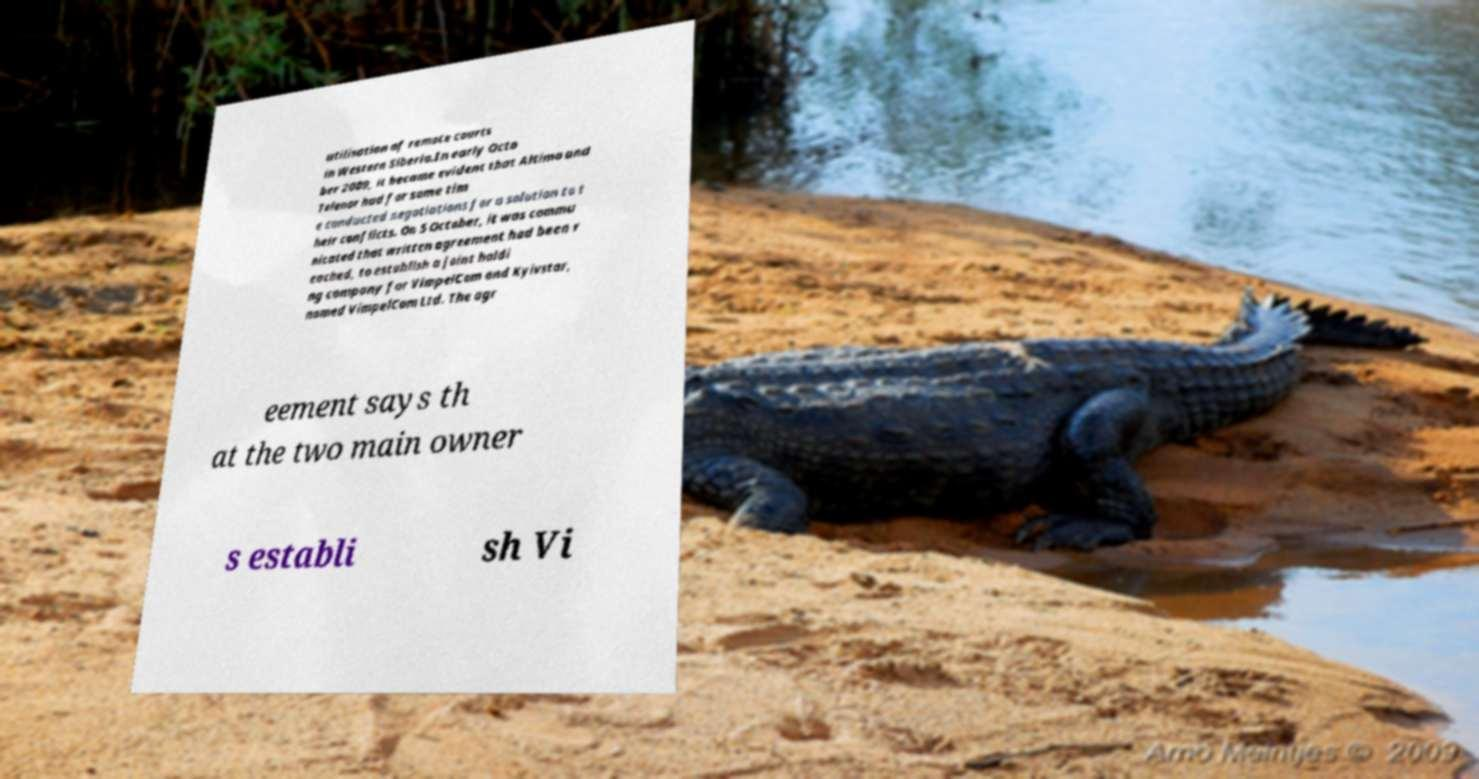Can you accurately transcribe the text from the provided image for me? utilisation of remote courts in Western Siberia.In early Octo ber 2009, it became evident that Altimo and Telenor had for some tim e conducted negotiations for a solution to t heir conflicts. On 5 October, it was commu nicated that written agreement had been r eached, to establish a joint holdi ng company for VimpelCom and Kyivstar, named VimpelCom Ltd. The agr eement says th at the two main owner s establi sh Vi 